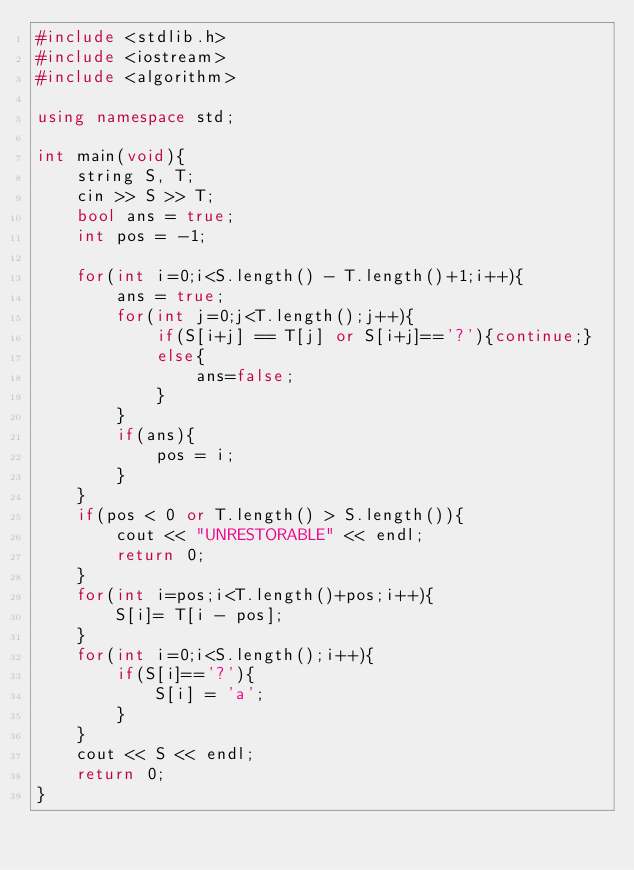Convert code to text. <code><loc_0><loc_0><loc_500><loc_500><_C++_>#include <stdlib.h>
#include <iostream>
#include <algorithm>

using namespace std;

int main(void){
    string S, T;
    cin >> S >> T;
    bool ans = true;
    int pos = -1;

    for(int i=0;i<S.length() - T.length()+1;i++){
        ans = true;
        for(int j=0;j<T.length();j++){
            if(S[i+j] == T[j] or S[i+j]=='?'){continue;}
            else{
                ans=false;
            }
        }
        if(ans){
            pos = i;
        }
    }
    if(pos < 0 or T.length() > S.length()){
        cout << "UNRESTORABLE" << endl;
        return 0;
    }
    for(int i=pos;i<T.length()+pos;i++){
        S[i]= T[i - pos];
    }
    for(int i=0;i<S.length();i++){
        if(S[i]=='?'){
            S[i] = 'a'; 
        }
    }
    cout << S << endl;
    return 0;
}</code> 